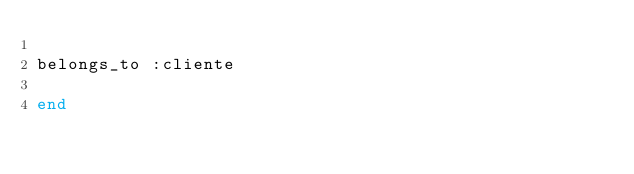<code> <loc_0><loc_0><loc_500><loc_500><_Ruby_>    
belongs_to :cliente

end
</code> 